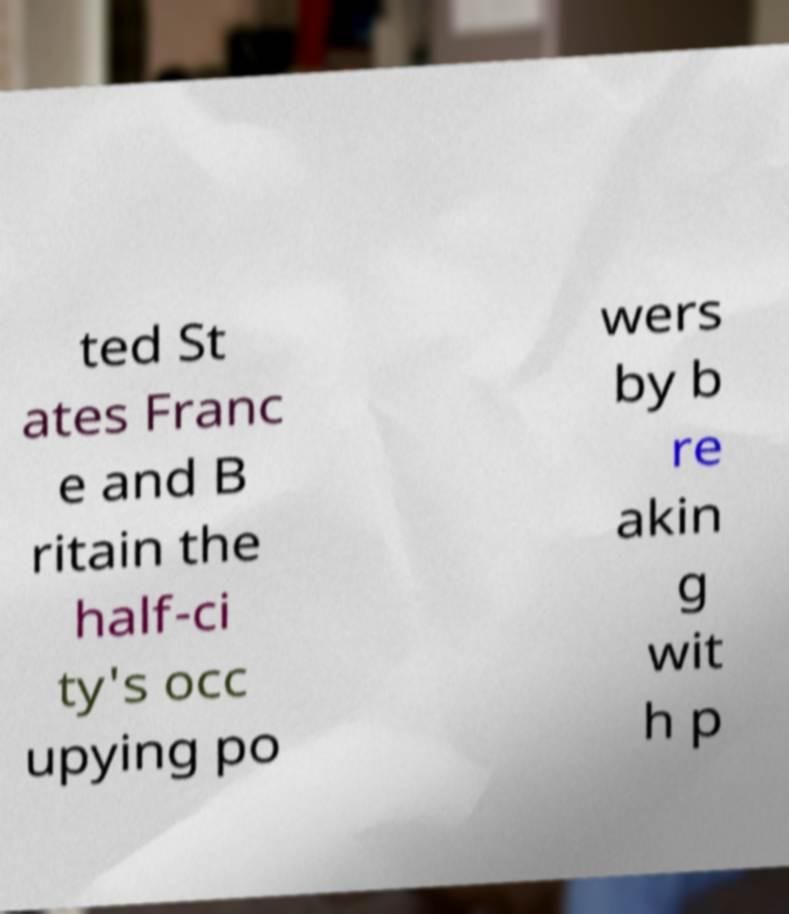Please read and relay the text visible in this image. What does it say? ted St ates Franc e and B ritain the half-ci ty's occ upying po wers by b re akin g wit h p 